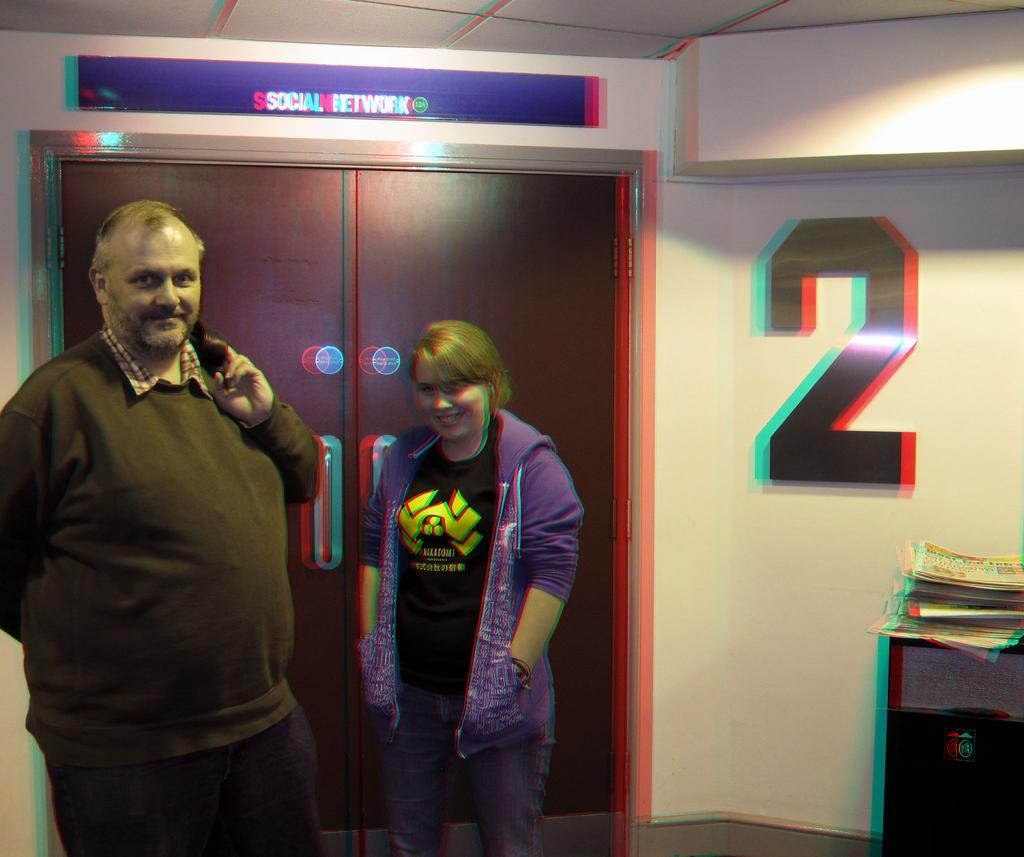Who is present in the image? There is a man and a woman in the image. What is the woman doing in the image? The woman is standing in the image. What are the man and woman doing together? The man and woman are talking in the image. What architectural feature can be seen in the image? There is a door in the image, and it is connected to a wall. How many fingers does the man have on his left hand in the image? There is no information about the man's fingers in the image, so it cannot be determined. 